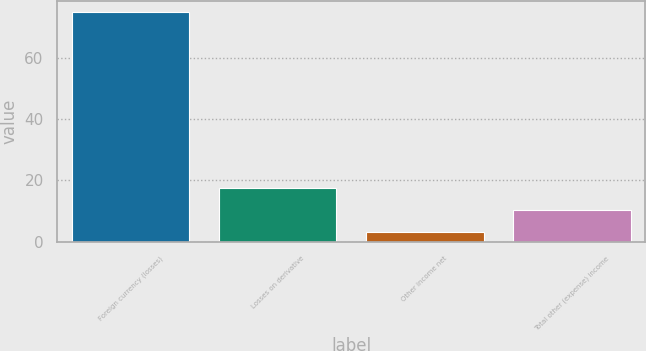Convert chart. <chart><loc_0><loc_0><loc_500><loc_500><bar_chart><fcel>Foreign currency (losses)<fcel>Losses on derivative<fcel>Other income net<fcel>Total other (expense) income<nl><fcel>75<fcel>17.4<fcel>3<fcel>10.2<nl></chart> 